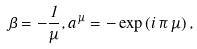<formula> <loc_0><loc_0><loc_500><loc_500>\beta = - \frac { 1 } { \mu } , a ^ { \, \mu } = - \exp \left ( i \, \pi \, \mu \right ) ,</formula> 